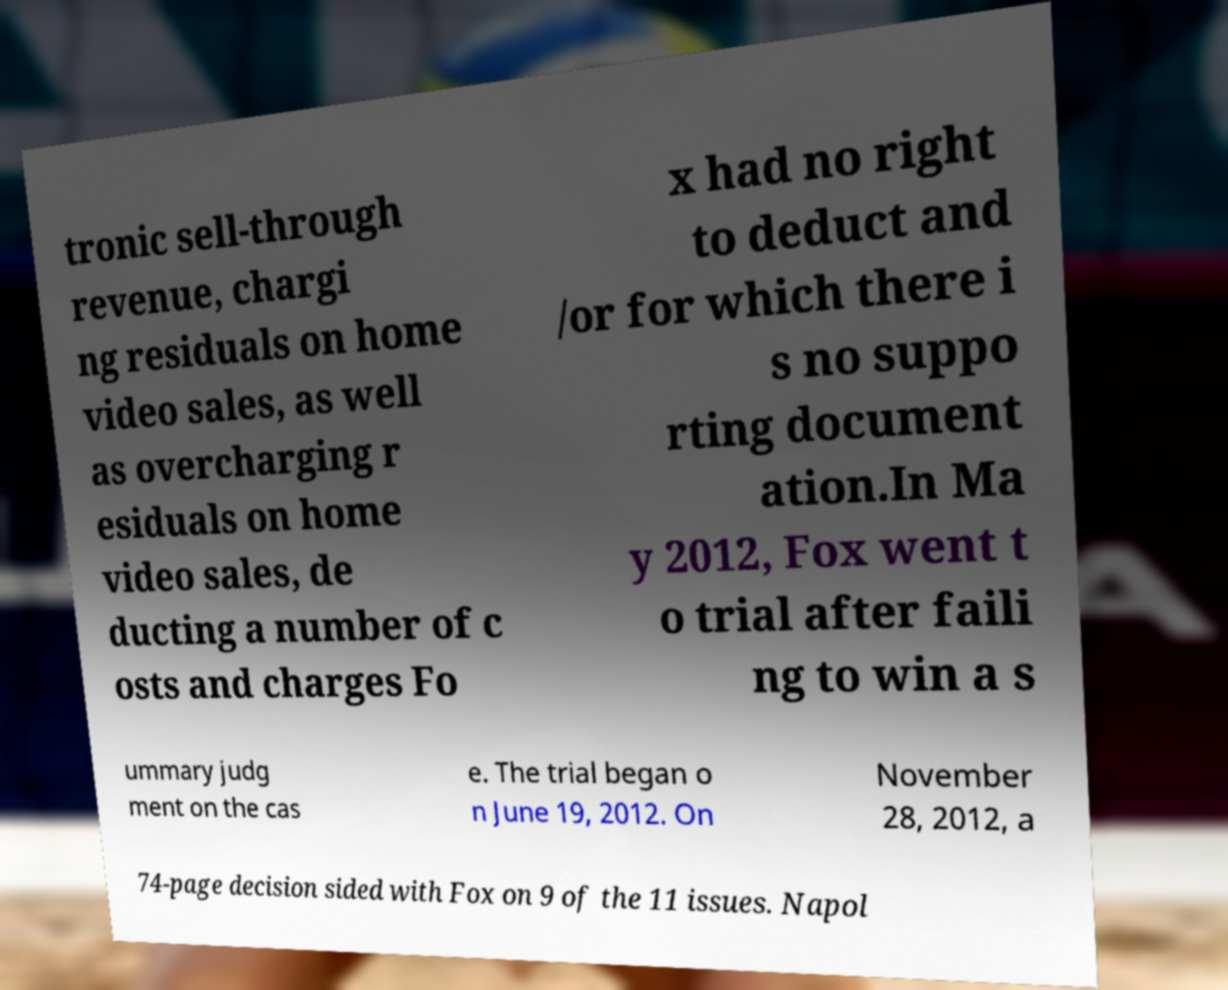Can you read and provide the text displayed in the image?This photo seems to have some interesting text. Can you extract and type it out for me? tronic sell-through revenue, chargi ng residuals on home video sales, as well as overcharging r esiduals on home video sales, de ducting a number of c osts and charges Fo x had no right to deduct and /or for which there i s no suppo rting document ation.In Ma y 2012, Fox went t o trial after faili ng to win a s ummary judg ment on the cas e. The trial began o n June 19, 2012. On November 28, 2012, a 74-page decision sided with Fox on 9 of the 11 issues. Napol 